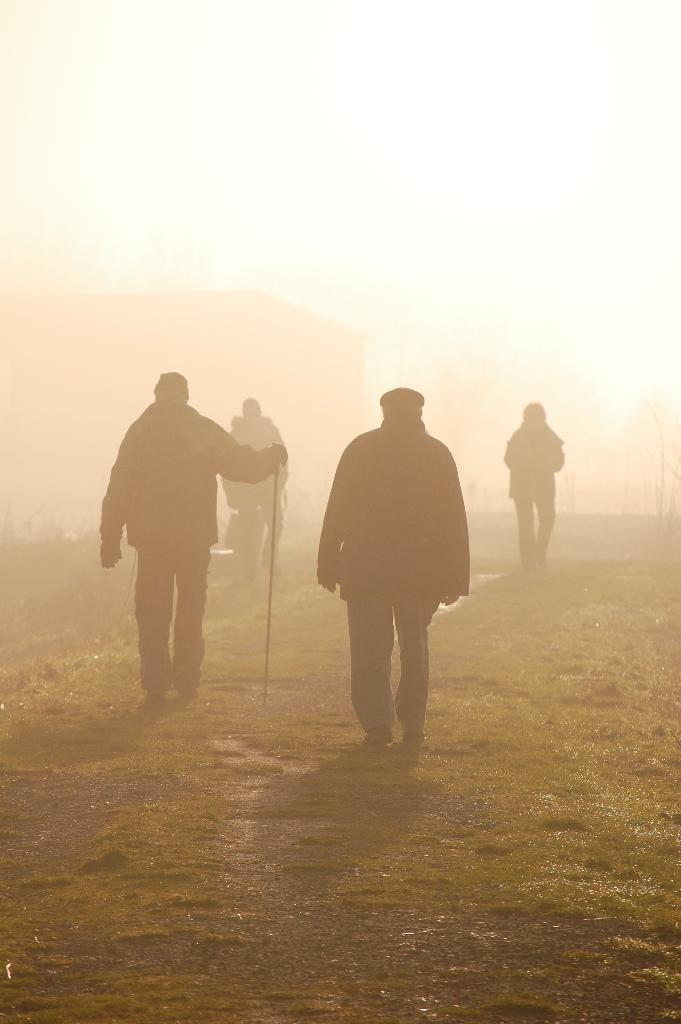What are the people in the image doing? The people in the image are walking on the grassland. Can you describe the person on the left side of the image? The person on the left side of the image is holding a stick. What is present on the left side of the image besides the person? There are plants on the left side of the image. What can be seen in the background of the image? The background of the image contains fog. What type of ship can be seen sailing through the fog in the image? There is no ship present in the image; it features people walking on the grassland with a person holding a stick and plants on the left side, and the background contains fog. 